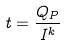Convert formula to latex. <formula><loc_0><loc_0><loc_500><loc_500>t = \frac { Q _ { P } } { I ^ { k } }</formula> 